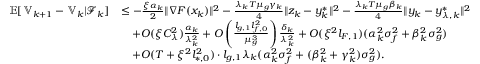Convert formula to latex. <formula><loc_0><loc_0><loc_500><loc_500>\begin{array} { r l } { \mathbb { E } [ \mathbb { V } _ { k + 1 } - \mathbb { V } _ { k } | \mathcal { F } _ { k } ] } & { \leq - \frac { \xi \alpha _ { k } } { 2 } \| \nabla F ( x _ { k } ) \| ^ { 2 } - \frac { \lambda _ { k } T \mu _ { g } \gamma _ { k } } { 4 } \| z _ { k } - y _ { k } ^ { * } \| ^ { 2 } - \frac { \lambda _ { k } T \mu _ { g } \beta _ { k } } { 4 } \| y _ { k } - y _ { \lambda , k } ^ { * } \| ^ { 2 } } \\ & { \quad + O ( \xi C _ { \lambda } ^ { 2 } ) \frac { \alpha _ { k } } { \lambda _ { k } ^ { 2 } } + O \left ( \frac { l _ { g , 1 } l _ { f , 0 } ^ { 2 } } { \mu _ { g } ^ { 3 } } \right ) \frac { \delta _ { k } } { \lambda _ { k } ^ { 2 } } + O ( \xi ^ { 2 } l _ { F , 1 } ) ( \alpha _ { k } ^ { 2 } \sigma _ { f } ^ { 2 } + \beta _ { k } ^ { 2 } \sigma _ { g } ^ { 2 } ) } \\ & { \quad + O ( T + \xi ^ { 2 } l _ { * , 0 } ^ { 2 } ) \cdot l _ { g , 1 } \lambda _ { k } ( \alpha _ { k } ^ { 2 } \sigma _ { f } ^ { 2 } + ( \beta _ { k } ^ { 2 } + \gamma _ { k } ^ { 2 } ) \sigma _ { g } ^ { 2 } ) . } \end{array}</formula> 